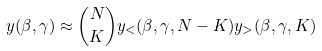<formula> <loc_0><loc_0><loc_500><loc_500>y ( \beta , \gamma ) \approx { N \choose K } y _ { < } ( \beta , \gamma , N - K ) y _ { > } ( \beta , \gamma , K )</formula> 